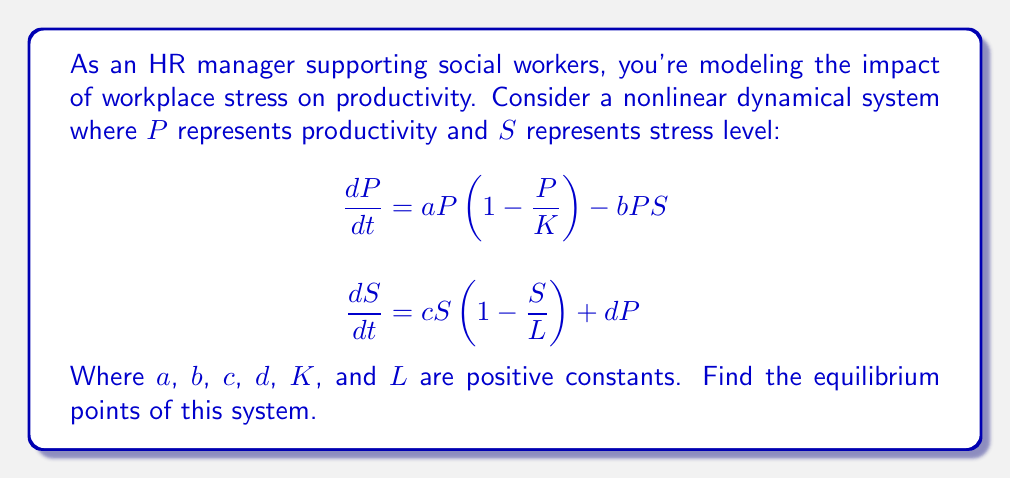Could you help me with this problem? To find the equilibrium points, we set both equations equal to zero:

1) $\frac{dP}{dt} = 0$ and $\frac{dS}{dt} = 0$

2) From $\frac{dP}{dt} = 0$:
   $aP(1-\frac{P}{K}) - bPS = 0$
   $P[a(1-\frac{P}{K}) - bS] = 0$

3) This gives us two possibilities:
   $P = 0$ or $a(1-\frac{P}{K}) - bS = 0$

4) From $\frac{dS}{dt} = 0$:
   $cS(1-\frac{S}{L}) + dP = 0$

5) Case 1: If $P = 0$, then from step 4:
   $cS(1-\frac{S}{L}) = 0$
   This gives $S = 0$ or $S = L$

6) Case 2: If $P \neq 0$, then from step 3:
   $S = \frac{a}{b}(1-\frac{P}{K})$

   Substituting this into the equation from step 4:
   $c(\frac{a}{b}(1-\frac{P}{K}))(1-\frac{\frac{a}{b}(1-\frac{P}{K})}{L}) + dP = 0$

7) This is a quadratic equation in $P$. Solving it (which is algebraically complex) would give us the non-zero equilibrium points.

Therefore, the equilibrium points are:
(0,0), (0,L), and potentially two more points from the quadratic equation in step 7.
Answer: (0,0), (0,L), and two potential additional points from a quadratic equation in P. 